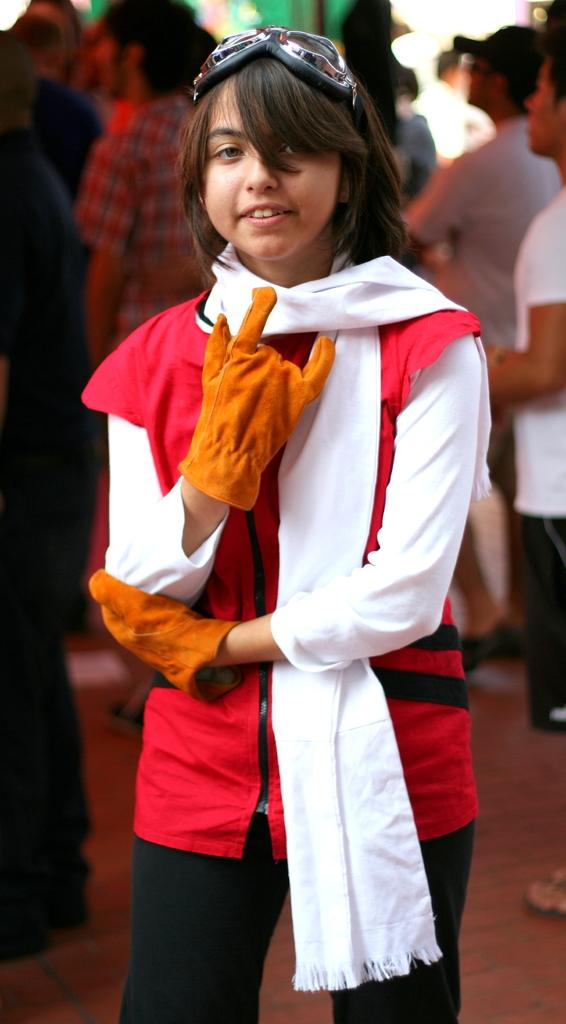Who is the main subject in the image? There is a girl in the image. What is the girl doing in the image? The girl is standing in the image. What accessories is the girl wearing in the image? The girl is wearing gloves in her hand and a scarf around her neck. Are there any other people in the image? Yes, there are other people standing behind the girl. What type of umbrella is the girl holding in the image? There is no umbrella present in the image. Can you compare the girl's outfit to the outfits of the people behind her? It is not possible to make a comparison of the girl's outfit to the outfits of the people behind her, as the provided facts do not give enough information about their clothing. 